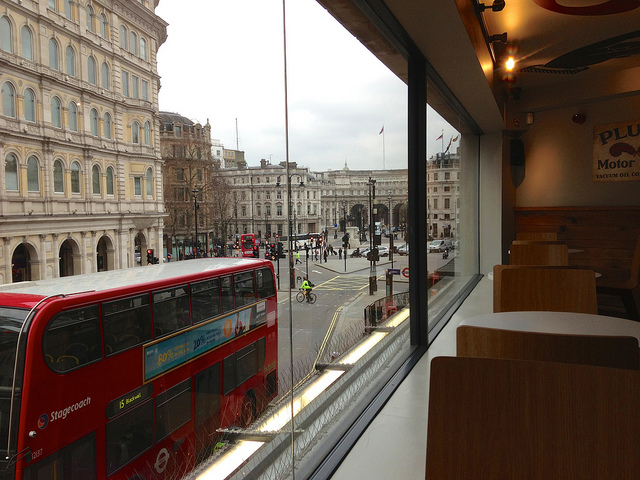<image>Are people seated at the tables in the picture? There are no people seated at the tables in the picture. Are people seated at the tables in the picture? No, there are no people seated at the tables in the picture. 